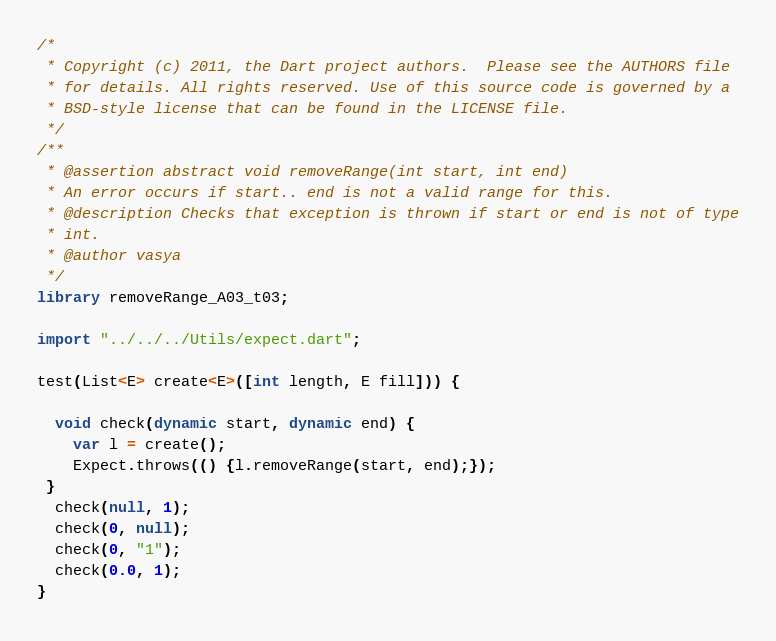Convert code to text. <code><loc_0><loc_0><loc_500><loc_500><_Dart_>/*
 * Copyright (c) 2011, the Dart project authors.  Please see the AUTHORS file
 * for details. All rights reserved. Use of this source code is governed by a
 * BSD-style license that can be found in the LICENSE file.
 */
/**
 * @assertion abstract void removeRange(int start, int end)
 * An error occurs if start.. end is not a valid range for this.
 * @description Checks that exception is thrown if start or end is not of type
 * int.
 * @author vasya
 */
library removeRange_A03_t03;

import "../../../Utils/expect.dart";

test(List<E> create<E>([int length, E fill])) {

  void check(dynamic start, dynamic end) {
    var l = create();
    Expect.throws(() {l.removeRange(start, end);});
 }
  check(null, 1);
  check(0, null);
  check(0, "1");
  check(0.0, 1);
}
</code> 